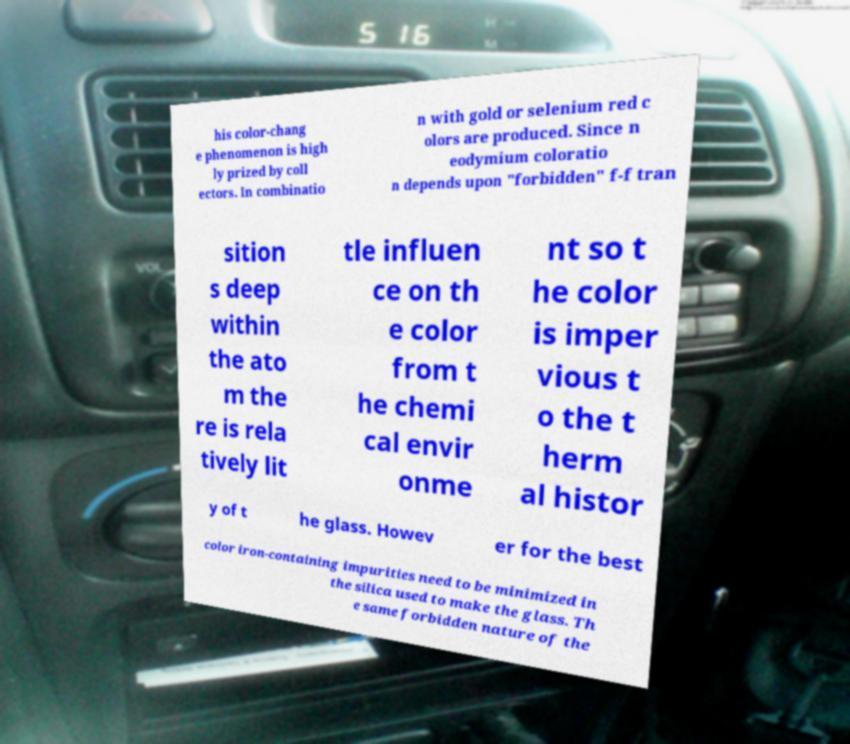I need the written content from this picture converted into text. Can you do that? his color-chang e phenomenon is high ly prized by coll ectors. In combinatio n with gold or selenium red c olors are produced. Since n eodymium coloratio n depends upon "forbidden" f-f tran sition s deep within the ato m the re is rela tively lit tle influen ce on th e color from t he chemi cal envir onme nt so t he color is imper vious t o the t herm al histor y of t he glass. Howev er for the best color iron-containing impurities need to be minimized in the silica used to make the glass. Th e same forbidden nature of the 